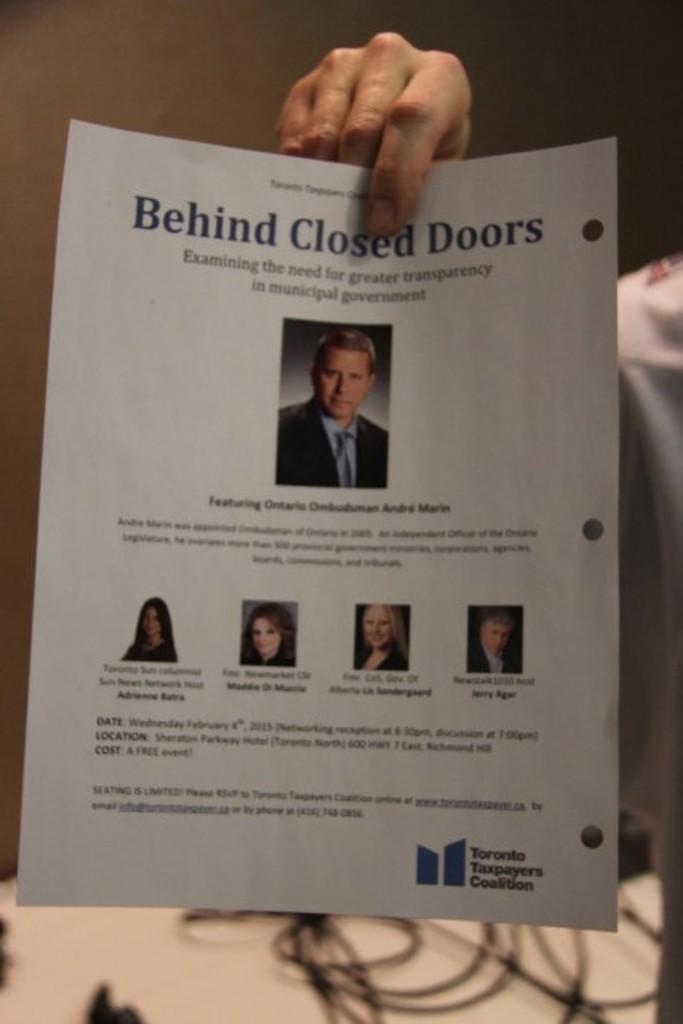In one or two sentences, can you explain what this image depicts? In this picture I can see in the middle there are photographs of humans on the paper and there is text. At the top there is a human hand, at the bottom there are cables. 